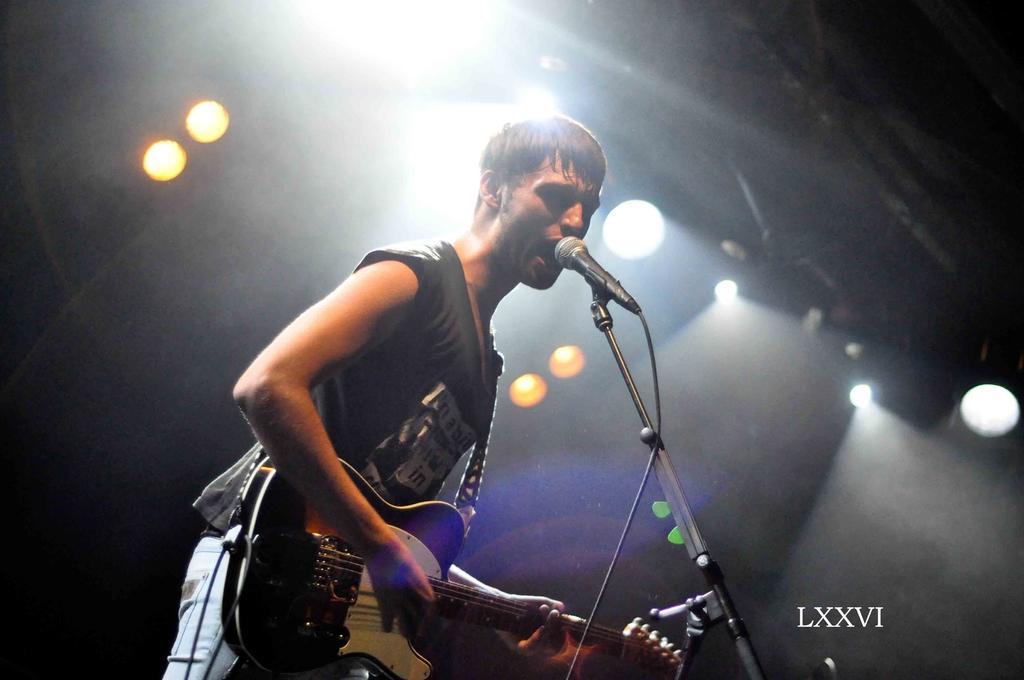How would you summarize this image in a sentence or two? There is a man singing on the mike. And he is playing guitar. On the background we can see some lights. 